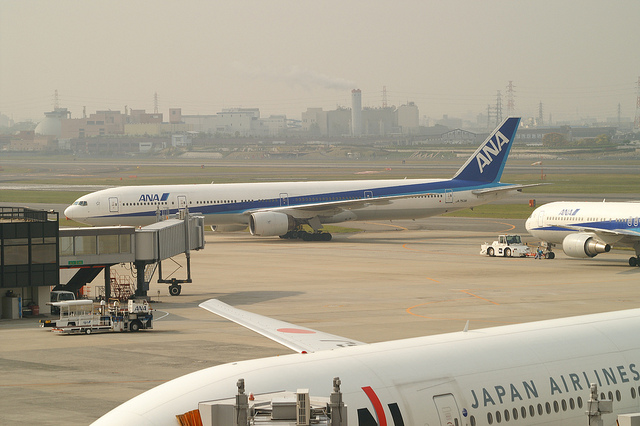How many prongs does the fork have? There is no fork visible in the image to count the prongs. The image depicts a scene at an airport with an ANA commercial airplane connected to an aerobridge, and parts of other commercial airplanes, including one from Japan Airlines, are also visible. 